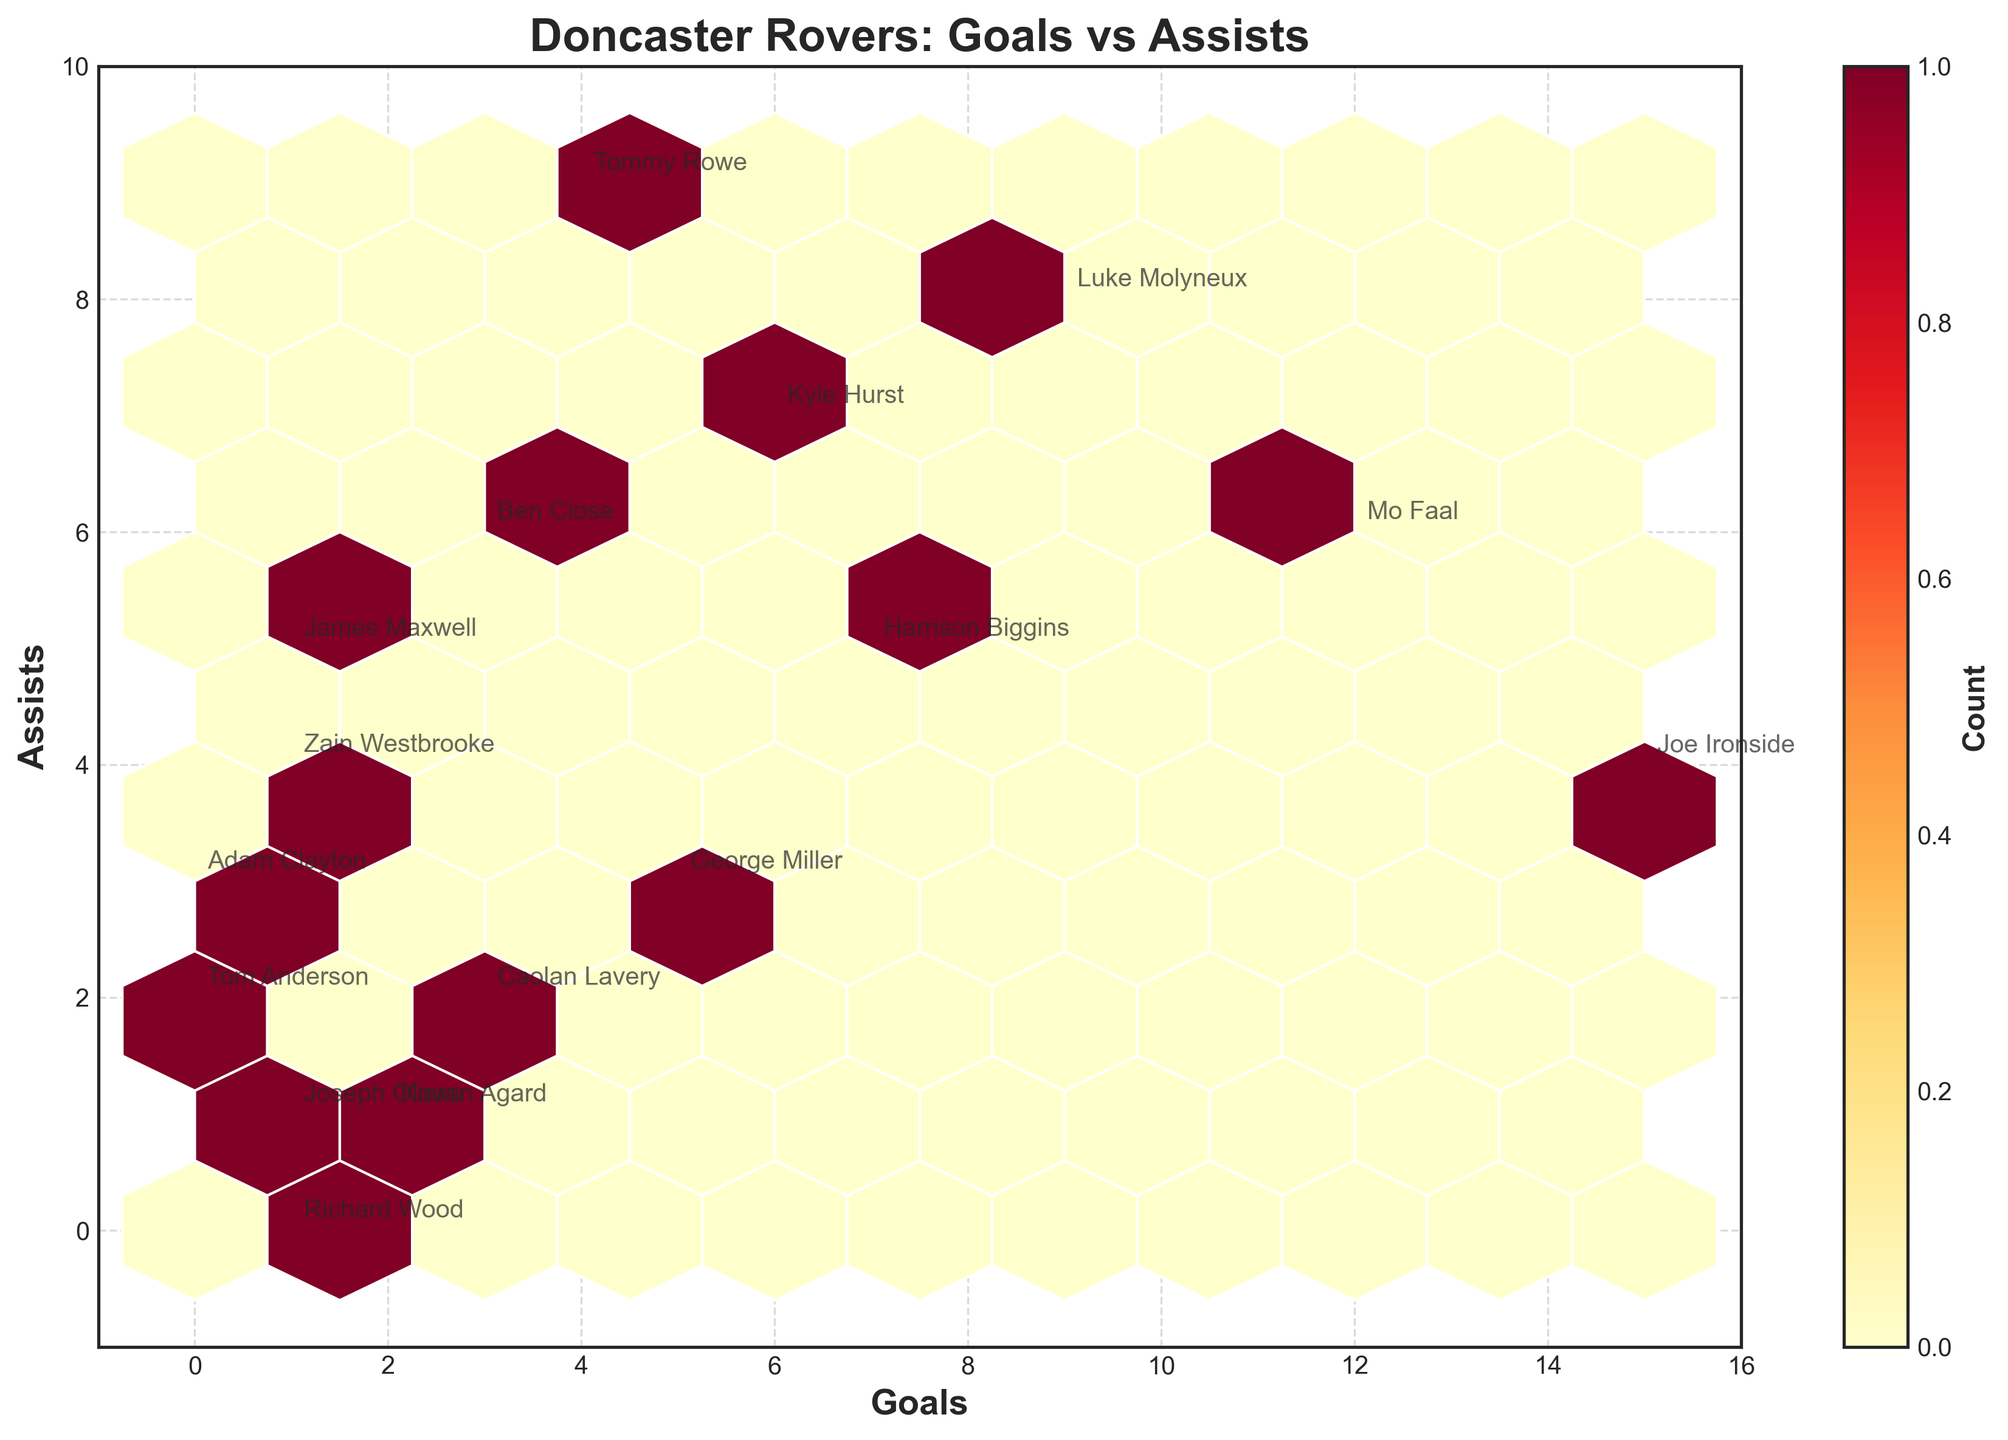Which player has the highest number of goals? Looking at the hexbin plot, identify the player with the point at the highest Goals value on the x-axis.
Answer: Joe Ironside What's the grid color where most data points are concentrated? Locate the hexbin on the plot which has the most intense color. This color indicates the highest concentration of data points.
Answer: Dark orange What is the title of the plot? Read the title at the top of the plot.
Answer: Doncaster Rovers: Goals vs Assists Which player has the highest number of assists? Identify which player is annotated at the highest point on the y-axis for Assists.
Answer: Tommy Rowe Are there more players with goals equal to assists or players with goals greater than assists? Compare the number of points on the y=x line (where Goals = Assists) with points above it (where Goals > Assists).
Answer: More with goals greater than assists Who has fewer assists, Caolan Lavery or Adam Clayton? Find the annotated points for Caolan Lavery and Adam Clayton on the plot and compare their y-axis values (Assists).
Answer: Caolan Lavery What's the total number of goals scored by Joe Ironside and Mo Faal? Add the Goals value for Joe Ironside and the Goals value for Mo Faal by locating these players on the plot.
Answer: 27 Which player is located at the coordinates (1,4) for Goals and Assists? Find the annotation on the hexbin plot for the point (1 Goals, 4 Assists).
Answer: Zain Westbrooke Are there any players who scored no goals? Look for annotated points on the plot where the Goals value is 0.
Answer: Yes Between George Miller and Kyle Hurst, who has more assists? Compare the y-axis values (Assists) for George Miller and Kyle Hurst from their annotated points on the plot.
Answer: Kyle Hurst 